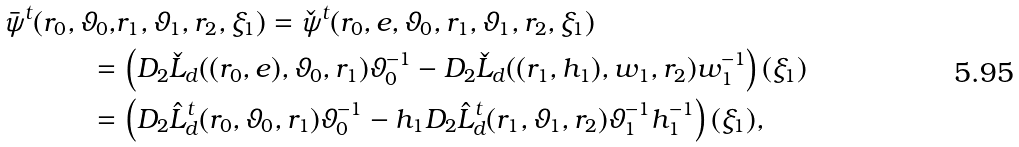Convert formula to latex. <formula><loc_0><loc_0><loc_500><loc_500>\bar { \psi } ^ { t } ( r _ { 0 } , \vartheta _ { 0 } , & r _ { 1 } , \vartheta _ { 1 } , r _ { 2 } , \xi _ { 1 } ) = \check { \psi } ^ { t } ( r _ { 0 } , e , \vartheta _ { 0 } , r _ { 1 } , \vartheta _ { 1 } , r _ { 2 } , \xi _ { 1 } ) \\ = & \, \left ( D _ { 2 } \check { L } _ { d } ( ( r _ { 0 } , e ) , \vartheta _ { 0 } , r _ { 1 } ) \vartheta _ { 0 } ^ { - 1 } - D _ { 2 } \check { L } _ { d } ( ( r _ { 1 } , h _ { 1 } ) , w _ { 1 } , r _ { 2 } ) w _ { 1 } ^ { - 1 } \right ) ( \xi _ { 1 } ) \\ = & \, \left ( D _ { 2 } \hat { L } _ { d } ^ { t } ( r _ { 0 } , \vartheta _ { 0 } , r _ { 1 } ) \vartheta _ { 0 } ^ { - 1 } - h _ { 1 } D _ { 2 } \hat { L } _ { d } ^ { t } ( r _ { 1 } , \vartheta _ { 1 } , r _ { 2 } ) \vartheta _ { 1 } ^ { - 1 } h _ { 1 } ^ { - 1 } \right ) ( \xi _ { 1 } ) ,</formula> 